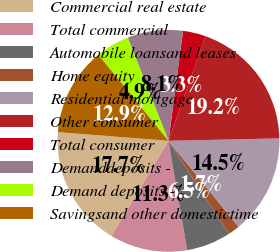Convert chart to OTSL. <chart><loc_0><loc_0><loc_500><loc_500><pie_chart><fcel>Commercial real estate<fcel>Total commercial<fcel>Automobile loansand leases<fcel>Home equity<fcel>Residential mortgage<fcel>Other consumer<fcel>Total consumer<fcel>Demanddeposits -<fcel>Demand deposits -<fcel>Savingsand other domestictime<nl><fcel>17.66%<fcel>11.28%<fcel>6.49%<fcel>1.7%<fcel>14.47%<fcel>19.25%<fcel>3.3%<fcel>8.09%<fcel>4.89%<fcel>12.87%<nl></chart> 